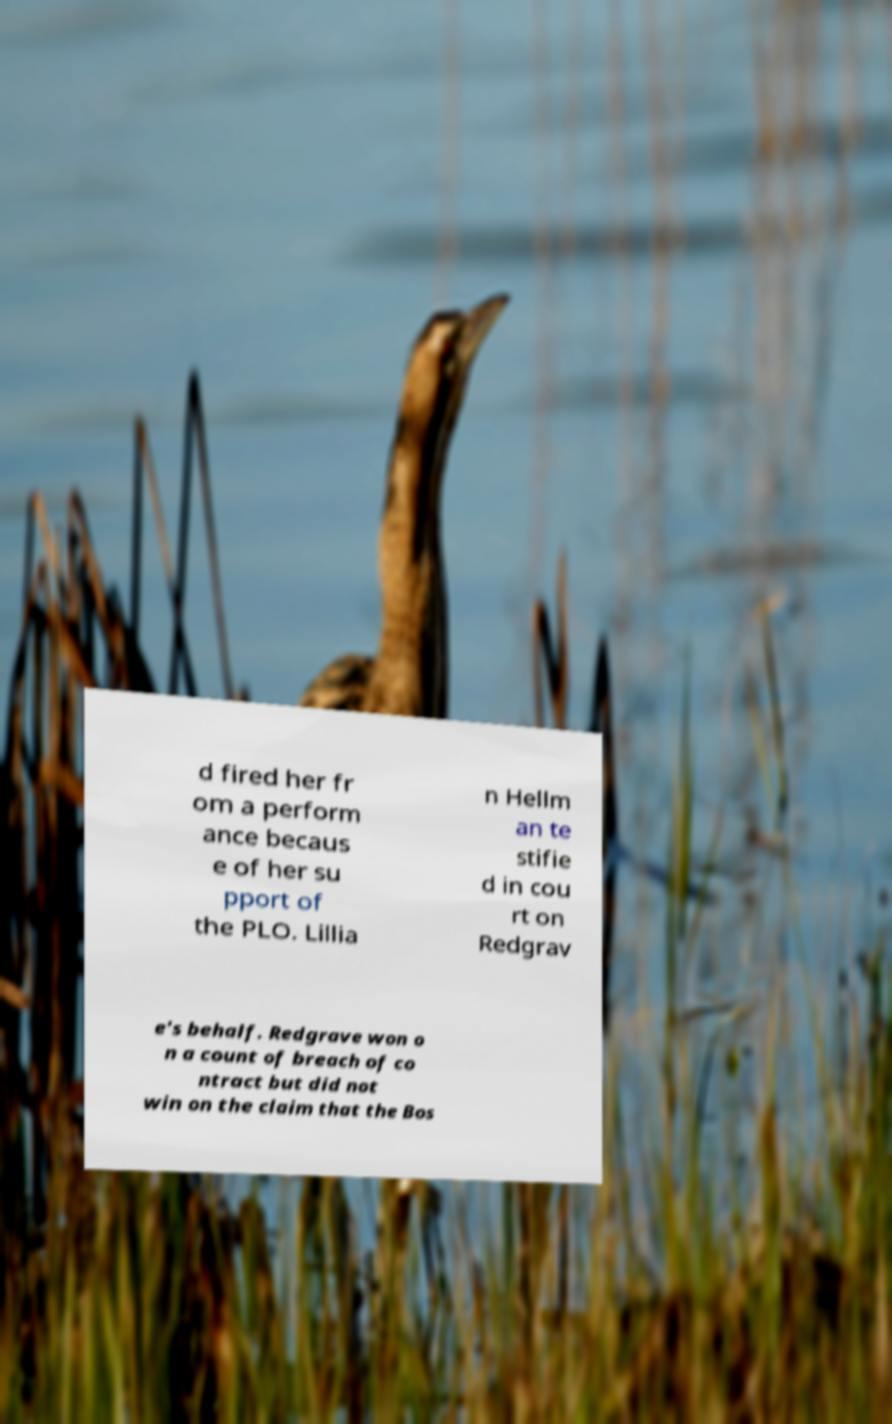Can you read and provide the text displayed in the image?This photo seems to have some interesting text. Can you extract and type it out for me? d fired her fr om a perform ance becaus e of her su pport of the PLO. Lillia n Hellm an te stifie d in cou rt on Redgrav e's behalf. Redgrave won o n a count of breach of co ntract but did not win on the claim that the Bos 